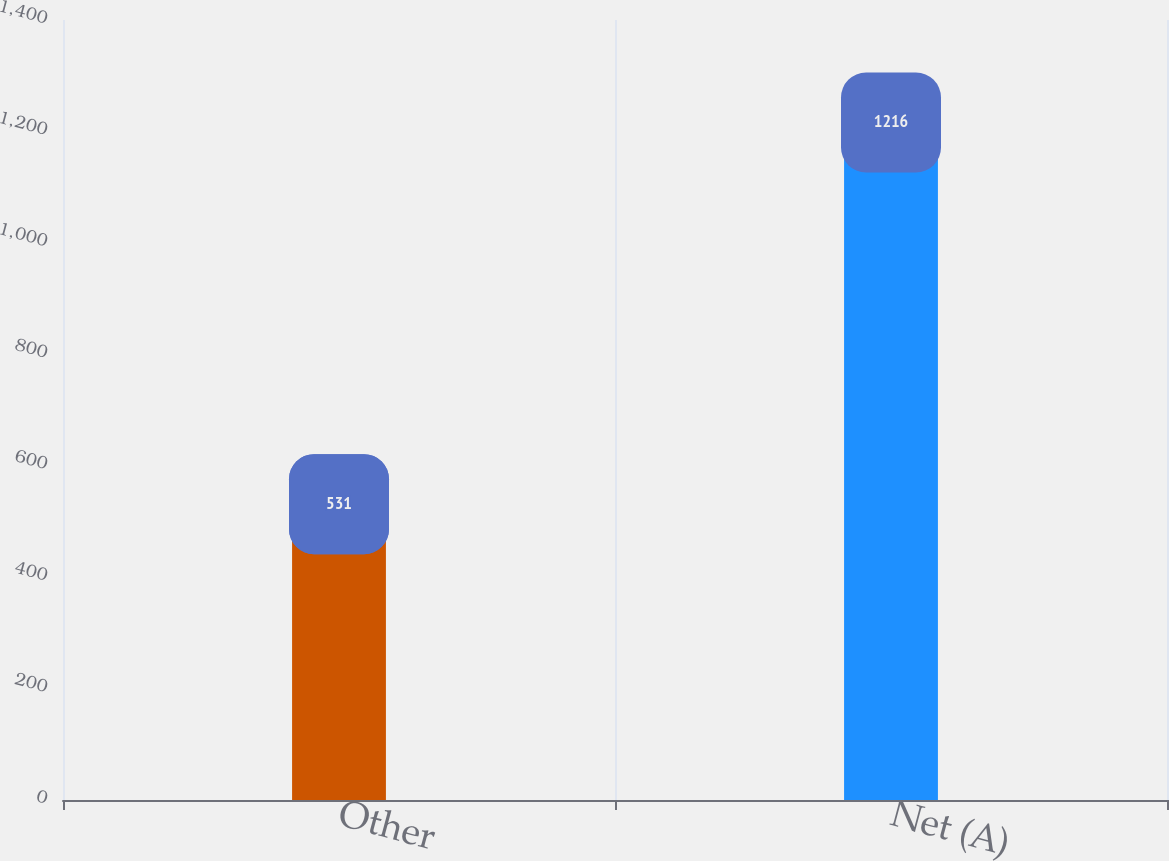Convert chart to OTSL. <chart><loc_0><loc_0><loc_500><loc_500><bar_chart><fcel>Other<fcel>Net (A)<nl><fcel>531<fcel>1216<nl></chart> 